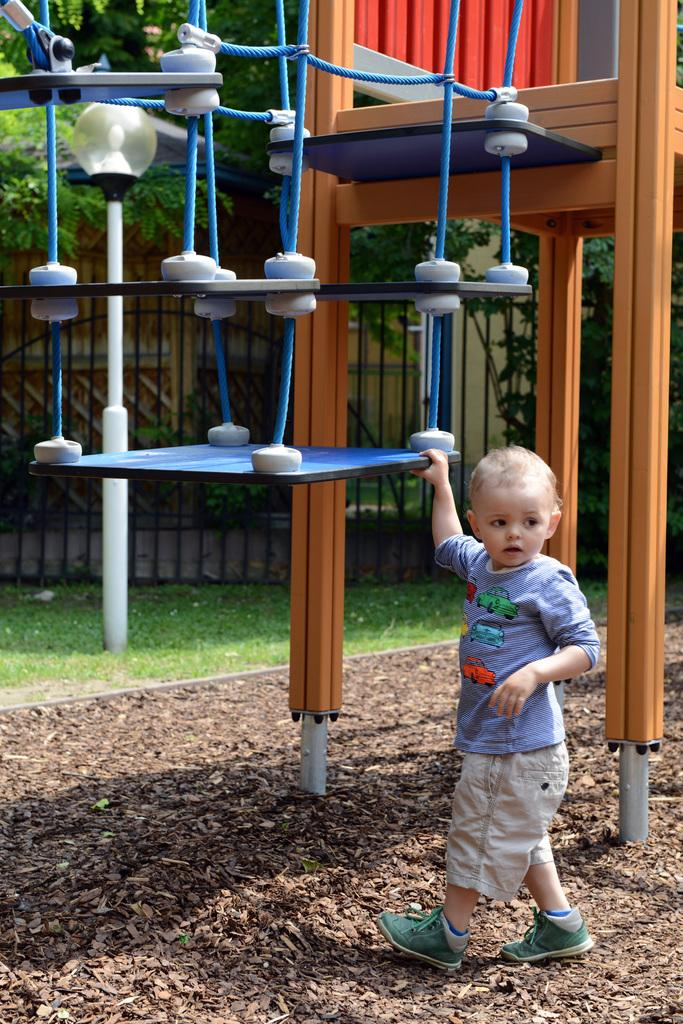What is the main subject of the image? The main subject of the image is a kid. What is the kid holding in the image? The kid is holding a fun ride. What can be seen in the background of the image? There are trees, a light, and a gate in the background of the image. Where is the cellar located in the image? There is no cellar present in the image. What type of magic is being performed by the kid in the image? There is no magic being performed in the image; the kid is simply holding a fun ride. 